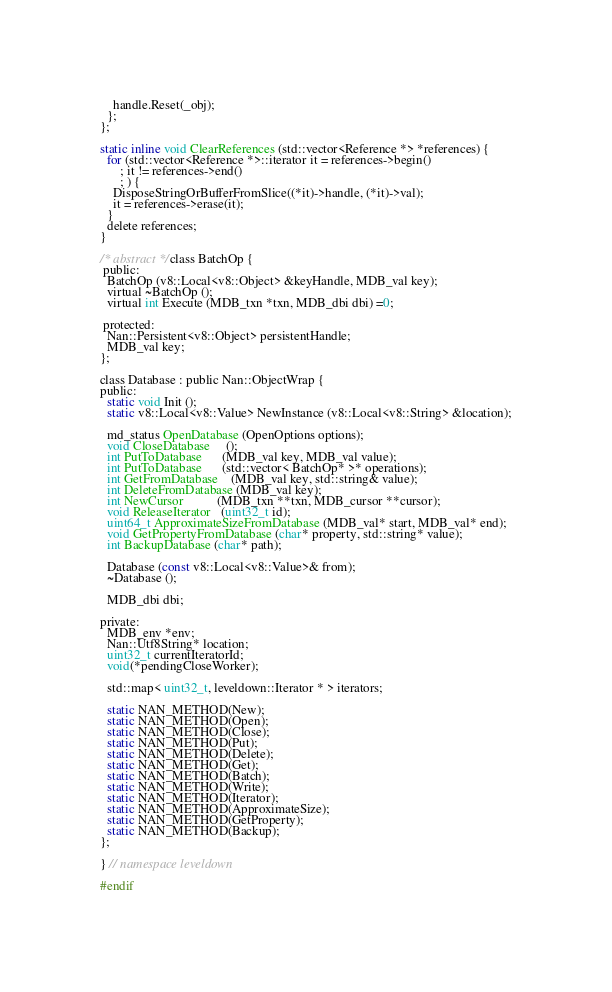Convert code to text. <code><loc_0><loc_0><loc_500><loc_500><_C_>    handle.Reset(_obj);
  };
};

static inline void ClearReferences (std::vector<Reference *> *references) {
  for (std::vector<Reference *>::iterator it = references->begin()
      ; it != references->end()
      ; ) {
    DisposeStringOrBufferFromSlice((*it)->handle, (*it)->val);
    it = references->erase(it);
  }
  delete references;
}

/* abstract */ class BatchOp {
 public:
  BatchOp (v8::Local<v8::Object> &keyHandle, MDB_val key);
  virtual ~BatchOp ();
  virtual int Execute (MDB_txn *txn, MDB_dbi dbi) =0;

 protected:
  Nan::Persistent<v8::Object> persistentHandle;
  MDB_val key;
};

class Database : public Nan::ObjectWrap {
public:
  static void Init ();
  static v8::Local<v8::Value> NewInstance (v8::Local<v8::String> &location);

  md_status OpenDatabase (OpenOptions options);
  void CloseDatabase     ();
  int PutToDatabase      (MDB_val key, MDB_val value);
  int PutToDatabase      (std::vector< BatchOp* >* operations);
  int GetFromDatabase    (MDB_val key, std::string& value);
  int DeleteFromDatabase (MDB_val key);
  int NewCursor          (MDB_txn **txn, MDB_cursor **cursor);
  void ReleaseIterator   (uint32_t id);
  uint64_t ApproximateSizeFromDatabase (MDB_val* start, MDB_val* end);
  void GetPropertyFromDatabase (char* property, std::string* value);
  int BackupDatabase (char* path);

  Database (const v8::Local<v8::Value>& from);
  ~Database ();

  MDB_dbi dbi;

private:
  MDB_env *env;
  Nan::Utf8String* location;
  uint32_t currentIteratorId;
  void(*pendingCloseWorker);

  std::map< uint32_t, leveldown::Iterator * > iterators;

  static NAN_METHOD(New);
  static NAN_METHOD(Open);
  static NAN_METHOD(Close);
  static NAN_METHOD(Put);
  static NAN_METHOD(Delete);
  static NAN_METHOD(Get);
  static NAN_METHOD(Batch);
  static NAN_METHOD(Write);
  static NAN_METHOD(Iterator);
  static NAN_METHOD(ApproximateSize);
  static NAN_METHOD(GetProperty);
  static NAN_METHOD(Backup);
};

} // namespace leveldown

#endif
</code> 